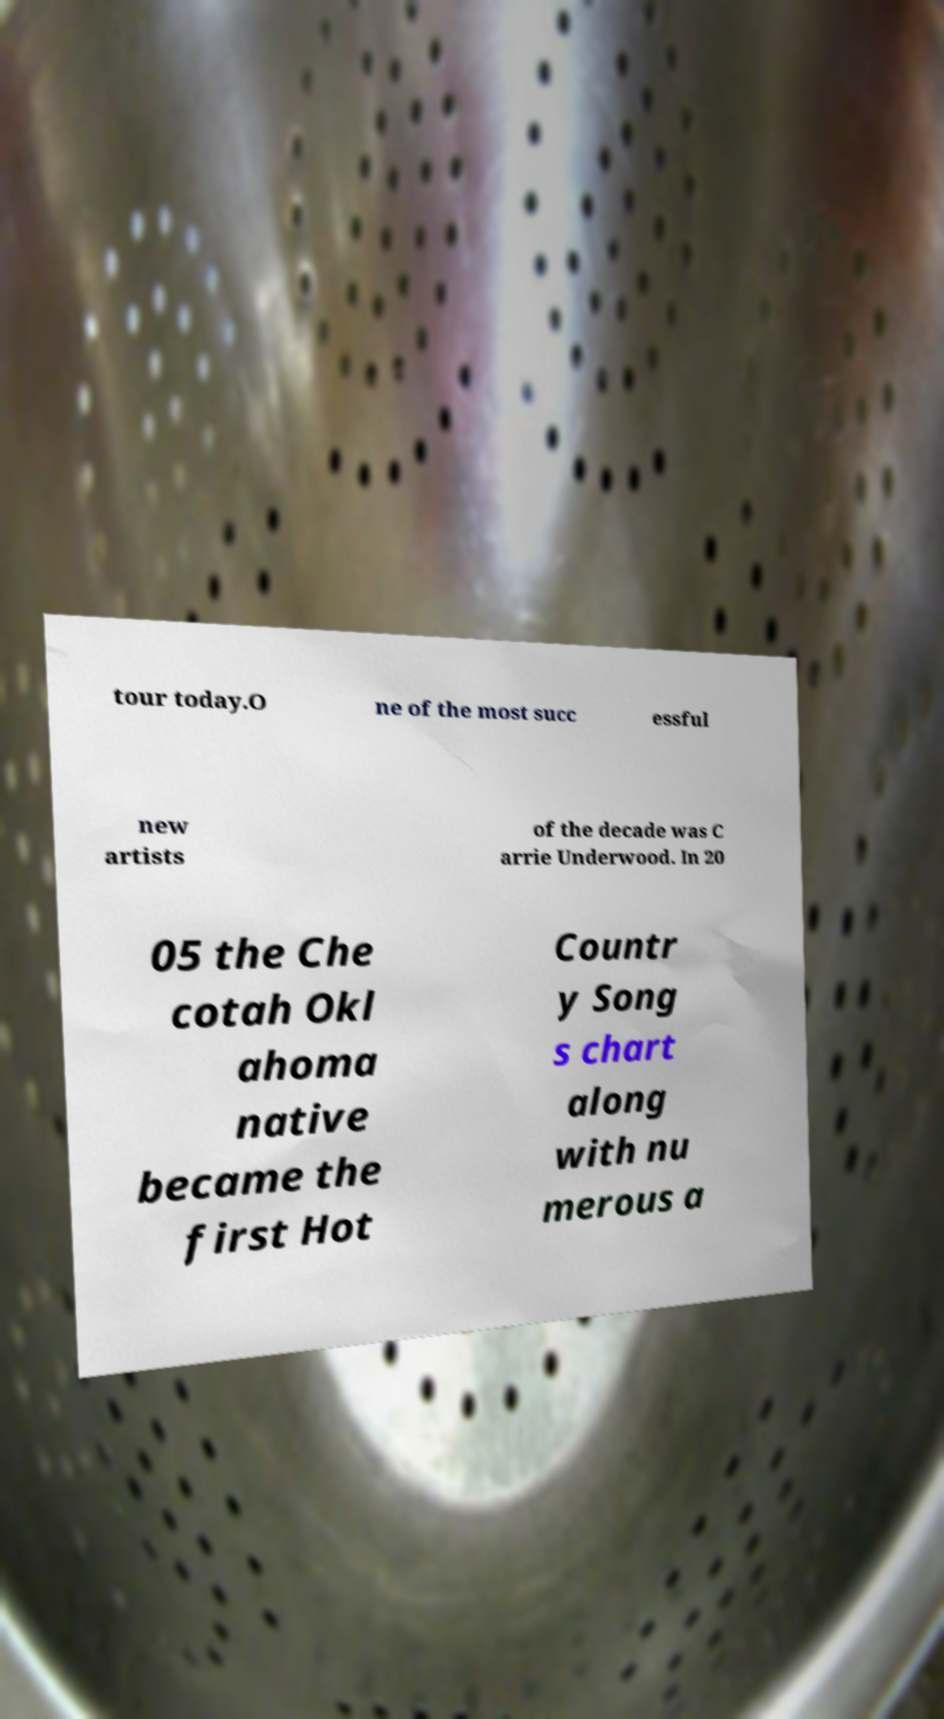For documentation purposes, I need the text within this image transcribed. Could you provide that? tour today.O ne of the most succ essful new artists of the decade was C arrie Underwood. In 20 05 the Che cotah Okl ahoma native became the first Hot Countr y Song s chart along with nu merous a 